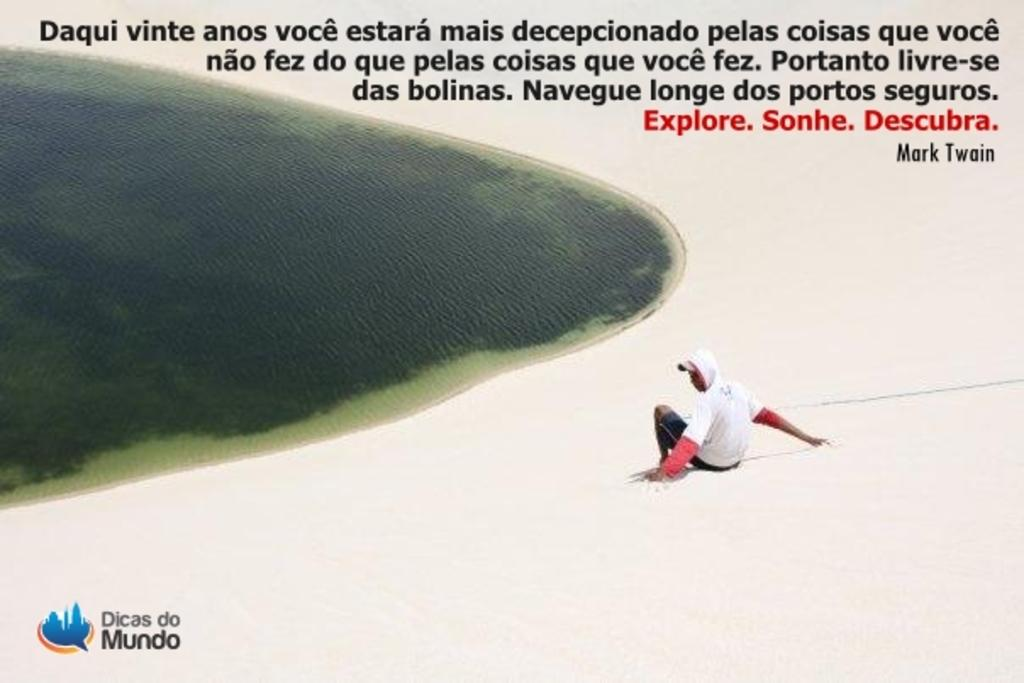Provide a one-sentence caption for the provided image. A tourist picture of a man on the beach for Dicas do Mundo. 